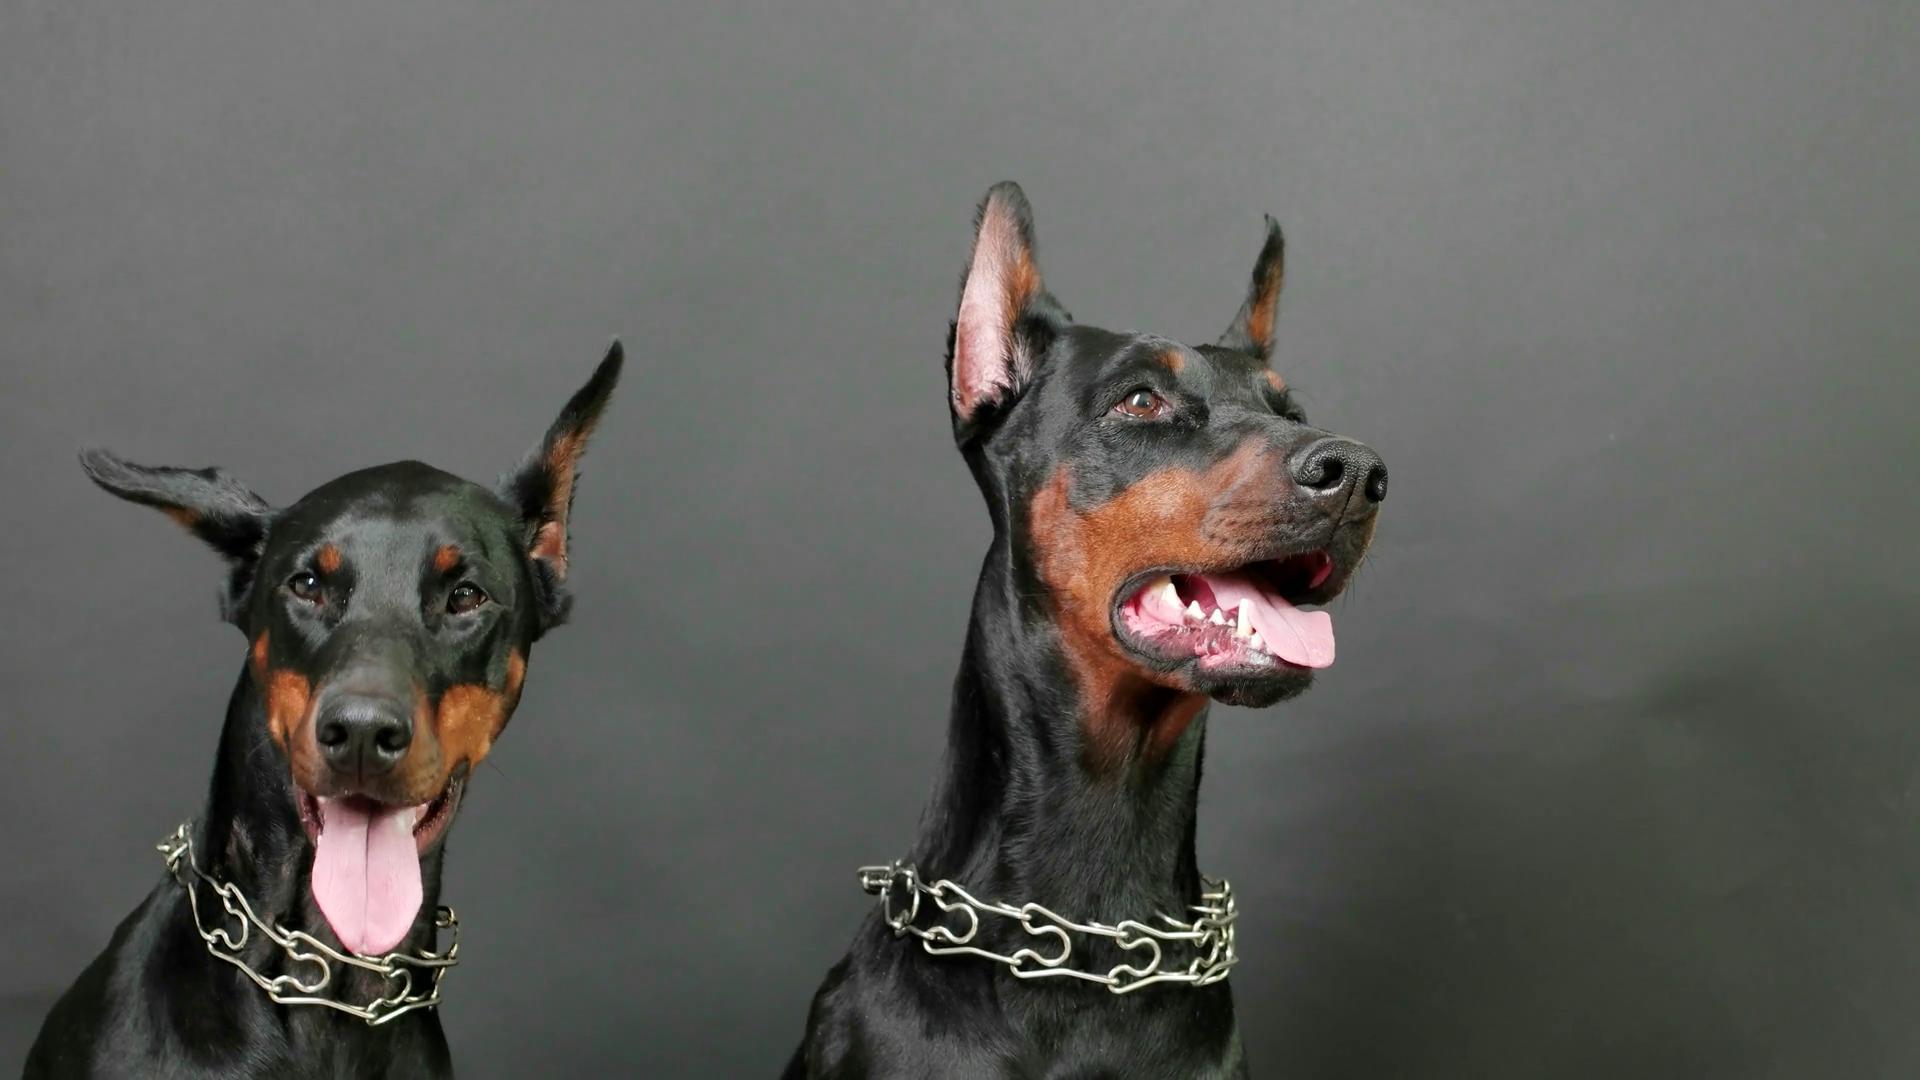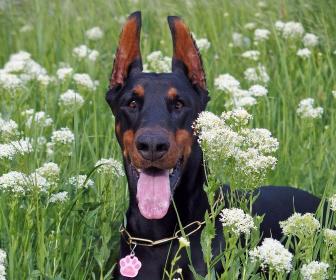The first image is the image on the left, the second image is the image on the right. For the images shown, is this caption "A total of three pointy-eared black-and-tan dobermans are shown, with at least one staring directly at the camera, and at least one gazing rightward." true? Answer yes or no. Yes. The first image is the image on the left, the second image is the image on the right. Given the left and right images, does the statement "The right image contains exactly two dogs." hold true? Answer yes or no. No. 